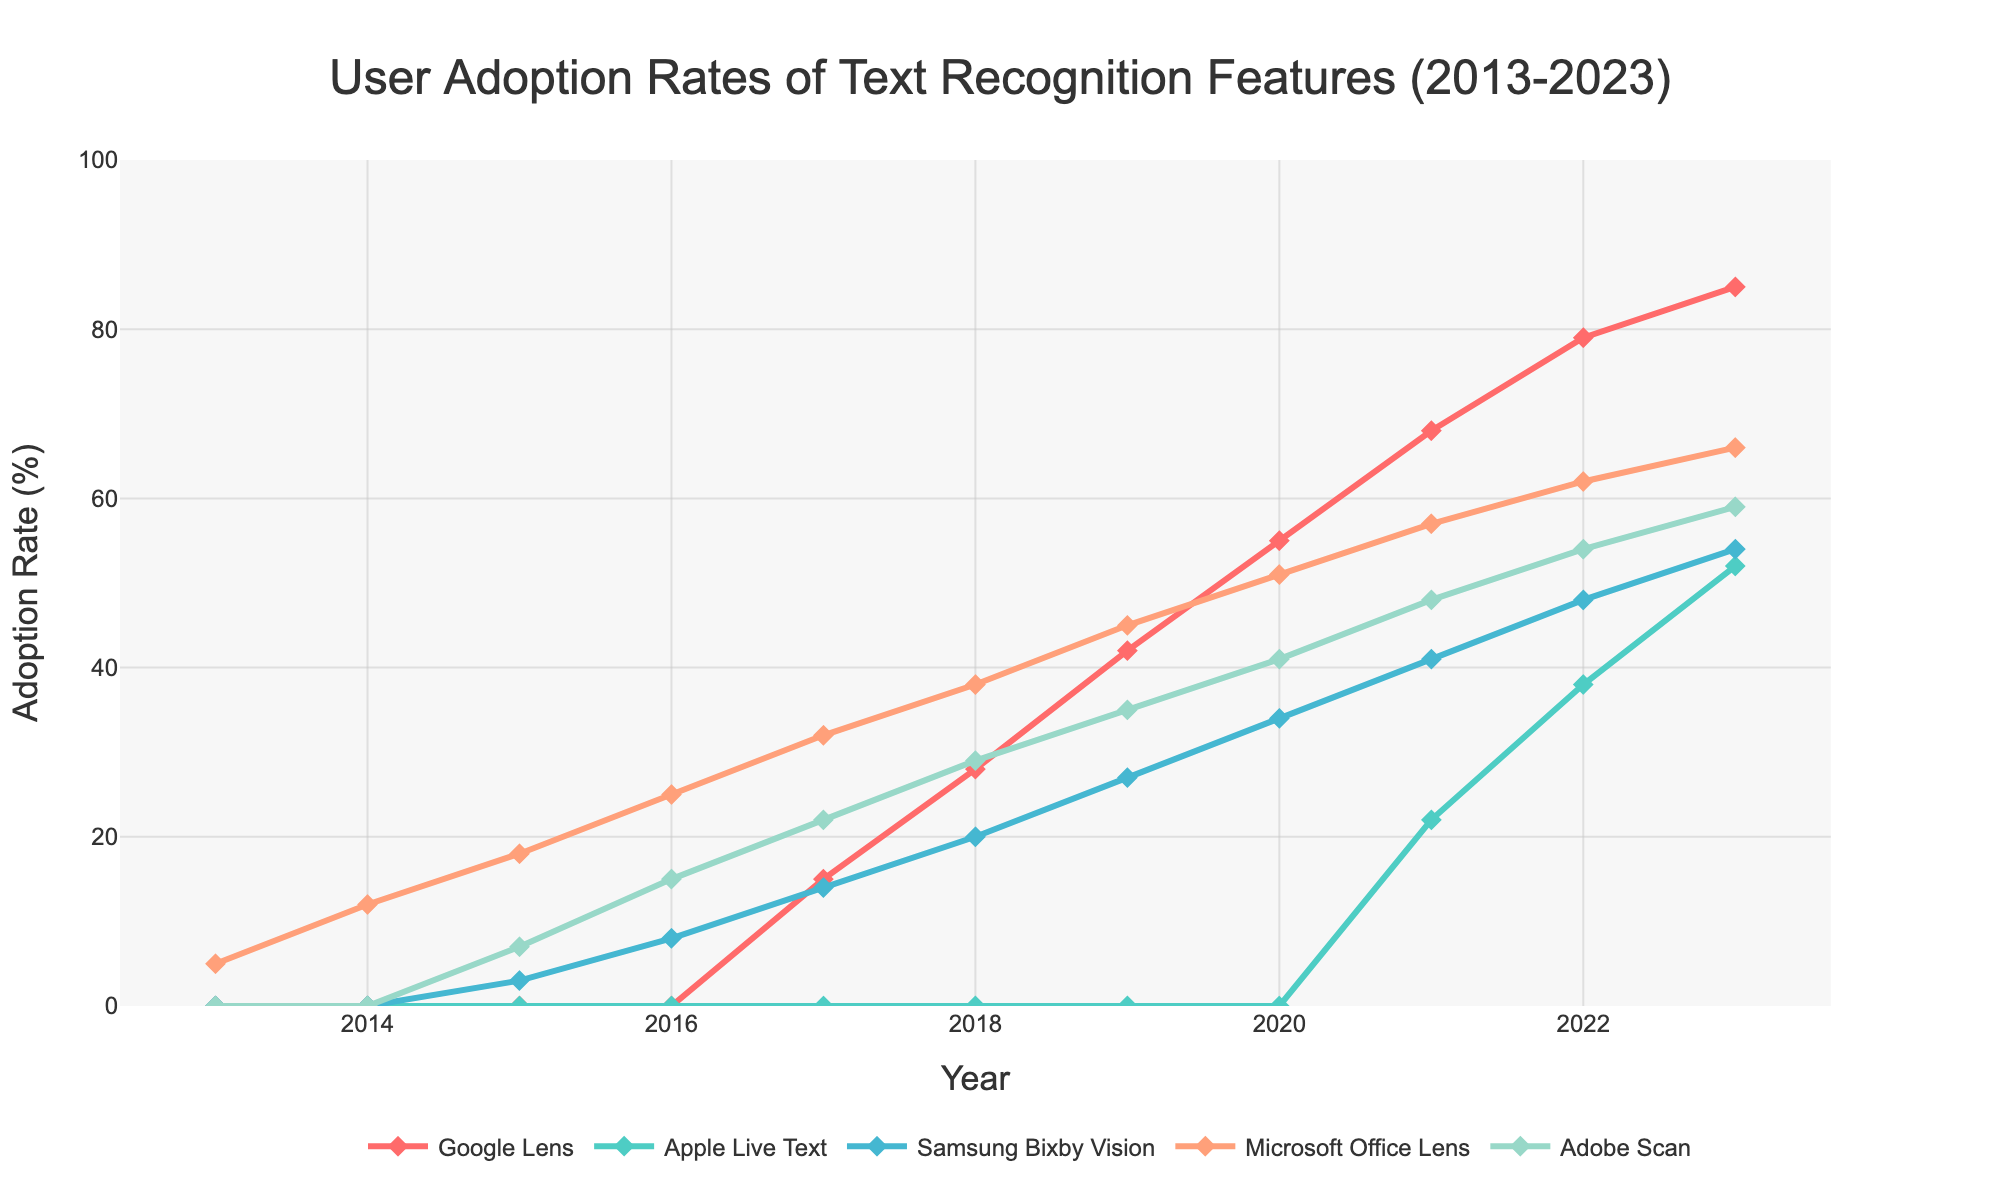How did the adoption rates change for Google Lens from 2017 to 2023? Look at the line representing Google Lens. In 2017, the adoption rate is at 15%. By 2023, it rises to 85%. The change is calculated as 85% - 15% = 70%.
Answer: 70% Which text recognition feature had the highest adoption rate in 2015? Observe the lines for the year 2015. Microsoft Office Lens has the highest adoption rate at 18%, compared to other features.
Answer: Microsoft Office Lens In what year did Apple Live Text first appear in the data? Check the line for Apple Live Text. The adoption rate is non-zero starting in 2021.
Answer: 2021 Compare the adoption rates of Samsung Bixby Vision and Adobe Scan in 2018. Which one is higher and by how much? For 2018, Samsung Bixby Vision's adoption rate is 20%, and Adobe Scan's rate is 29%. The difference is 29% - 20% = 9%. Adobe Scan has a higher rate by 9%.
Answer: Adobe Scan by 9% What is the overall trend of Microsoft Office Lens from 2013 to 2023? Microsoft Office Lens shows a consistent upward trend in adoption rates from 5% in 2013 to 66% in 2023.
Answer: Upward trend How does the growth rate of Adobe Scan from 2016 to 2020 compare to the growth rate of Google Lens in the same period? For Adobe Scan: From 15% (2016) to 41% (2020), the growth is 41% - 15% = 26%. For Google Lens: From 0% (2016) to 55% (2020), the growth is 55% - 0% = 55%. Google Lens's growth is higher.
Answer: Google Lens has higher growth Which feature had the slowest initial adoption but eventually gained momentum? Apple Live Text has zero adoption rates until 2021 and shows steady growth starting from that point.
Answer: Apple Live Text What is the difference in adoption rates between Samsung Bixby Vision and Google Lens in 2023? In 2023, Samsung Bixby Vision has 54% and Google Lens has 85%. The difference is 85% - 54% = 31%.
Answer: 31% Between what years does Microsoft Office Lens see the highest increase in adoption rate? The most significant increase for Microsoft Office Lens is observed between 2013 (5%) and 2014 (12%), where the increase is 12% - 5% = 7%.
Answer: 2013 to 2014 